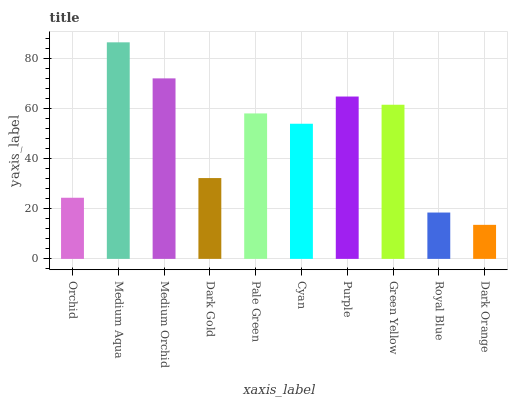Is Dark Orange the minimum?
Answer yes or no. Yes. Is Medium Aqua the maximum?
Answer yes or no. Yes. Is Medium Orchid the minimum?
Answer yes or no. No. Is Medium Orchid the maximum?
Answer yes or no. No. Is Medium Aqua greater than Medium Orchid?
Answer yes or no. Yes. Is Medium Orchid less than Medium Aqua?
Answer yes or no. Yes. Is Medium Orchid greater than Medium Aqua?
Answer yes or no. No. Is Medium Aqua less than Medium Orchid?
Answer yes or no. No. Is Pale Green the high median?
Answer yes or no. Yes. Is Cyan the low median?
Answer yes or no. Yes. Is Medium Aqua the high median?
Answer yes or no. No. Is Medium Aqua the low median?
Answer yes or no. No. 